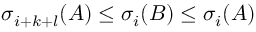Convert formula to latex. <formula><loc_0><loc_0><loc_500><loc_500>\sigma _ { i + k + l } ( A ) \leq \sigma _ { i } ( B ) \leq \sigma _ { i } ( A )</formula> 